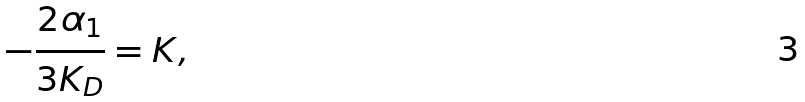<formula> <loc_0><loc_0><loc_500><loc_500>- \frac { 2 \alpha _ { 1 } } { 3 K _ { D } } = K ,</formula> 